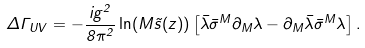<formula> <loc_0><loc_0><loc_500><loc_500>\Delta \Gamma _ { U V } = - \frac { i g ^ { 2 } } { 8 \pi ^ { 2 } } \ln ( M \tilde { s } ( z ) ) \left [ \bar { \lambda } \bar { \sigma } ^ { M } \partial _ { M } \lambda - \partial _ { M } \bar { \lambda } \bar { \sigma } ^ { M } \lambda \right ] .</formula> 